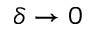Convert formula to latex. <formula><loc_0><loc_0><loc_500><loc_500>\delta \rightarrow 0</formula> 